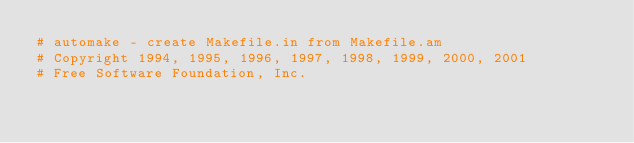<code> <loc_0><loc_0><loc_500><loc_500><_Perl_># automake - create Makefile.in from Makefile.am
# Copyright 1994, 1995, 1996, 1997, 1998, 1999, 2000, 2001
# Free Software Foundation, Inc.
</code> 